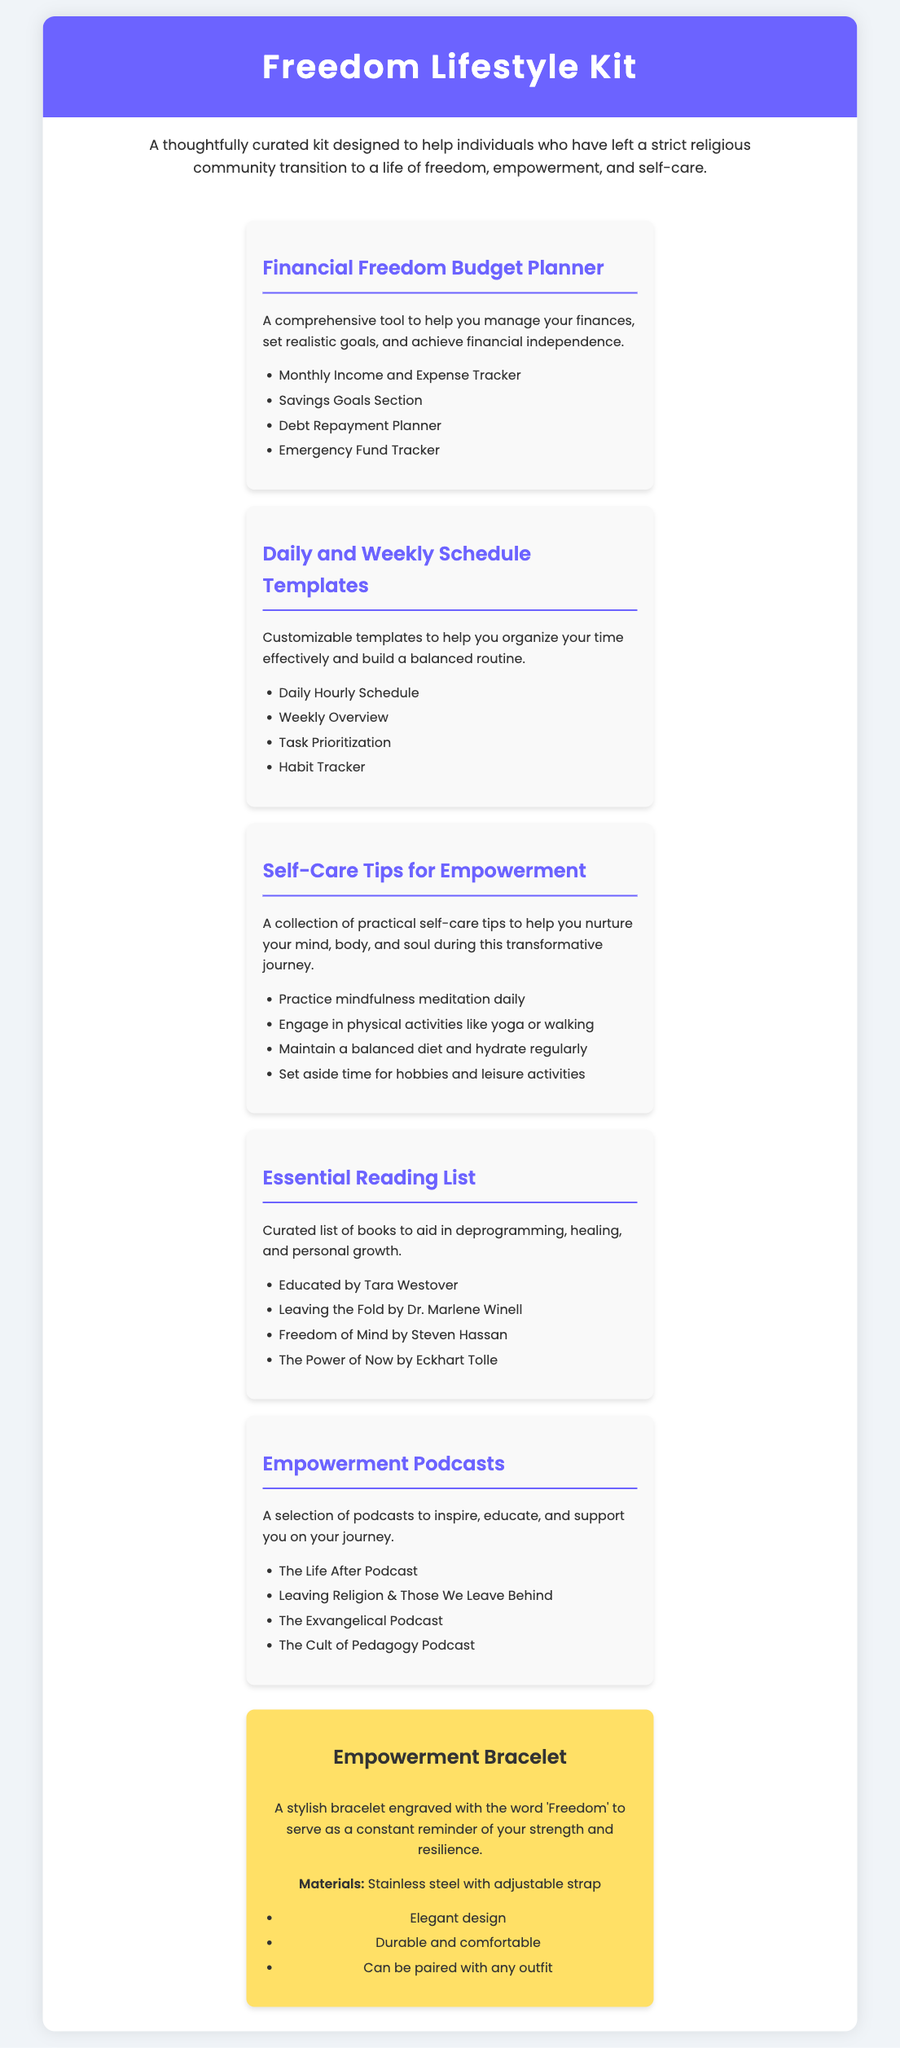What is the title of the kit? The title of the kit is presented prominently at the top of the document, indicating the main focus of the content.
Answer: Freedom Lifestyle Kit How many items are included in the kit? The document outlines various items included in the kit, which are listed under different headings.
Answer: 6 What is the purpose of the Financial Freedom Budget Planner? The document explains the primary function of the planner, emphasizing its role in managing finances.
Answer: Achieve financial independence Name one self-care tip included in the kit. The kit provides several self-care tips, and one example is specifically mentioned in the self-care section.
Answer: Practice mindfulness meditation daily What is engraved on the Empowerment Bracelet? The document specifies the engraving on the bracelet that serves as a reminder of personal strength.
Answer: Freedom Which book is part of the Essential Reading List? The document provides a list of books that aid in deprogramming and healing, including specific titles.
Answer: Educated by Tara Westover What type of material is used for the Empowerment Bracelet? The document details the materials used in making the bracelet, highlighting its quality.
Answer: Stainless steel What is the color of the header background? The document describes the color scheme used, particularly for the header section.
Answer: Purple 